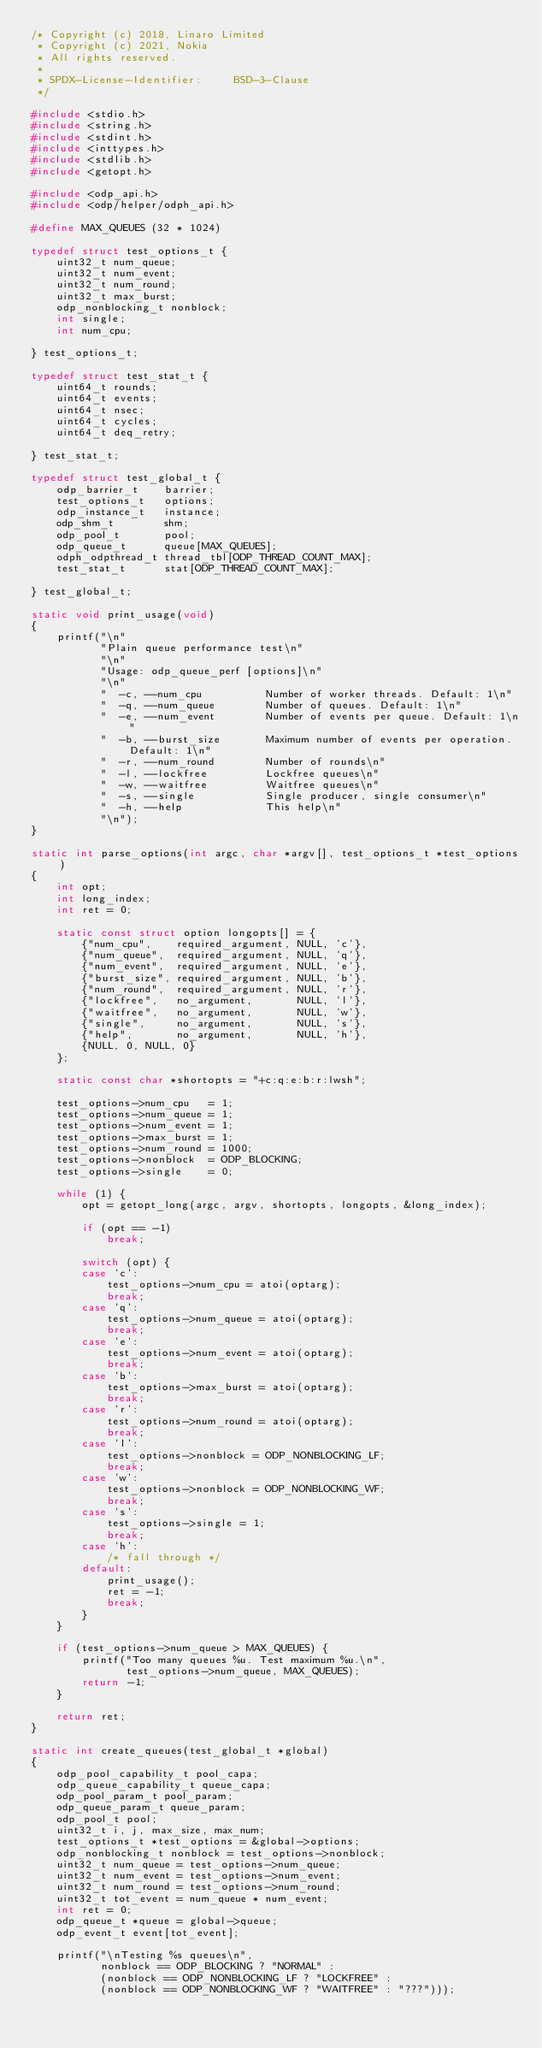Convert code to text. <code><loc_0><loc_0><loc_500><loc_500><_C_>/* Copyright (c) 2018, Linaro Limited
 * Copyright (c) 2021, Nokia
 * All rights reserved.
 *
 * SPDX-License-Identifier:     BSD-3-Clause
 */

#include <stdio.h>
#include <string.h>
#include <stdint.h>
#include <inttypes.h>
#include <stdlib.h>
#include <getopt.h>

#include <odp_api.h>
#include <odp/helper/odph_api.h>

#define MAX_QUEUES (32 * 1024)

typedef struct test_options_t {
	uint32_t num_queue;
	uint32_t num_event;
	uint32_t num_round;
	uint32_t max_burst;
	odp_nonblocking_t nonblock;
	int single;
	int num_cpu;

} test_options_t;

typedef struct test_stat_t {
	uint64_t rounds;
	uint64_t events;
	uint64_t nsec;
	uint64_t cycles;
	uint64_t deq_retry;

} test_stat_t;

typedef struct test_global_t {
	odp_barrier_t    barrier;
	test_options_t   options;
	odp_instance_t   instance;
	odp_shm_t        shm;
	odp_pool_t       pool;
	odp_queue_t      queue[MAX_QUEUES];
	odph_odpthread_t thread_tbl[ODP_THREAD_COUNT_MAX];
	test_stat_t      stat[ODP_THREAD_COUNT_MAX];

} test_global_t;

static void print_usage(void)
{
	printf("\n"
	       "Plain queue performance test\n"
	       "\n"
	       "Usage: odp_queue_perf [options]\n"
	       "\n"
	       "  -c, --num_cpu          Number of worker threads. Default: 1\n"
	       "  -q, --num_queue        Number of queues. Default: 1\n"
	       "  -e, --num_event        Number of events per queue. Default: 1\n"
	       "  -b, --burst_size       Maximum number of events per operation. Default: 1\n"
	       "  -r, --num_round        Number of rounds\n"
	       "  -l, --lockfree         Lockfree queues\n"
	       "  -w, --waitfree         Waitfree queues\n"
	       "  -s, --single           Single producer, single consumer\n"
	       "  -h, --help             This help\n"
	       "\n");
}

static int parse_options(int argc, char *argv[], test_options_t *test_options)
{
	int opt;
	int long_index;
	int ret = 0;

	static const struct option longopts[] = {
		{"num_cpu",    required_argument, NULL, 'c'},
		{"num_queue",  required_argument, NULL, 'q'},
		{"num_event",  required_argument, NULL, 'e'},
		{"burst_size", required_argument, NULL, 'b'},
		{"num_round",  required_argument, NULL, 'r'},
		{"lockfree",   no_argument,       NULL, 'l'},
		{"waitfree",   no_argument,       NULL, 'w'},
		{"single",     no_argument,       NULL, 's'},
		{"help",       no_argument,       NULL, 'h'},
		{NULL, 0, NULL, 0}
	};

	static const char *shortopts = "+c:q:e:b:r:lwsh";

	test_options->num_cpu   = 1;
	test_options->num_queue = 1;
	test_options->num_event = 1;
	test_options->max_burst = 1;
	test_options->num_round = 1000;
	test_options->nonblock  = ODP_BLOCKING;
	test_options->single    = 0;

	while (1) {
		opt = getopt_long(argc, argv, shortopts, longopts, &long_index);

		if (opt == -1)
			break;

		switch (opt) {
		case 'c':
			test_options->num_cpu = atoi(optarg);
			break;
		case 'q':
			test_options->num_queue = atoi(optarg);
			break;
		case 'e':
			test_options->num_event = atoi(optarg);
			break;
		case 'b':
			test_options->max_burst = atoi(optarg);
			break;
		case 'r':
			test_options->num_round = atoi(optarg);
			break;
		case 'l':
			test_options->nonblock = ODP_NONBLOCKING_LF;
			break;
		case 'w':
			test_options->nonblock = ODP_NONBLOCKING_WF;
			break;
		case 's':
			test_options->single = 1;
			break;
		case 'h':
			/* fall through */
		default:
			print_usage();
			ret = -1;
			break;
		}
	}

	if (test_options->num_queue > MAX_QUEUES) {
		printf("Too many queues %u. Test maximum %u.\n",
		       test_options->num_queue, MAX_QUEUES);
		return -1;
	}

	return ret;
}

static int create_queues(test_global_t *global)
{
	odp_pool_capability_t pool_capa;
	odp_queue_capability_t queue_capa;
	odp_pool_param_t pool_param;
	odp_queue_param_t queue_param;
	odp_pool_t pool;
	uint32_t i, j, max_size, max_num;
	test_options_t *test_options = &global->options;
	odp_nonblocking_t nonblock = test_options->nonblock;
	uint32_t num_queue = test_options->num_queue;
	uint32_t num_event = test_options->num_event;
	uint32_t num_round = test_options->num_round;
	uint32_t tot_event = num_queue * num_event;
	int ret = 0;
	odp_queue_t *queue = global->queue;
	odp_event_t event[tot_event];

	printf("\nTesting %s queues\n",
	       nonblock == ODP_BLOCKING ? "NORMAL" :
	       (nonblock == ODP_NONBLOCKING_LF ? "LOCKFREE" :
	       (nonblock == ODP_NONBLOCKING_WF ? "WAITFREE" : "???")));</code> 